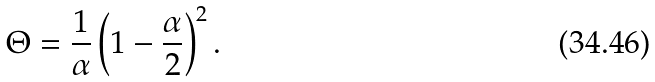Convert formula to latex. <formula><loc_0><loc_0><loc_500><loc_500>\Theta = { \frac { 1 } { \alpha } } \left ( 1 - { \frac { \alpha } { 2 } } \right ) ^ { 2 } .</formula> 